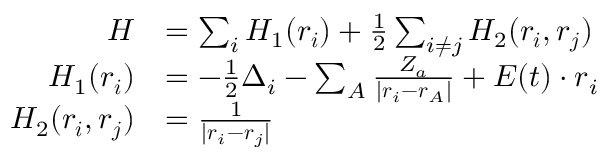Convert formula to latex. <formula><loc_0><loc_0><loc_500><loc_500>\begin{array} { r l } { H } & { = \sum _ { i } H _ { 1 } ( r _ { i } ) + \frac { 1 } { 2 } \sum _ { i \neq j } H _ { 2 } ( r _ { i } , r _ { j } ) } \\ { H _ { 1 } ( r _ { i } ) } & { = - \frac { 1 } { 2 } \Delta _ { i } - \sum _ { A } \frac { Z _ { a } } { | r _ { i } - r _ { A } | } + E ( t ) \cdot r _ { i } } \\ { H _ { 2 } ( r _ { i } , r _ { j } ) } & { = \frac { 1 } { | r _ { i } - r _ { j } | } } \end{array}</formula> 